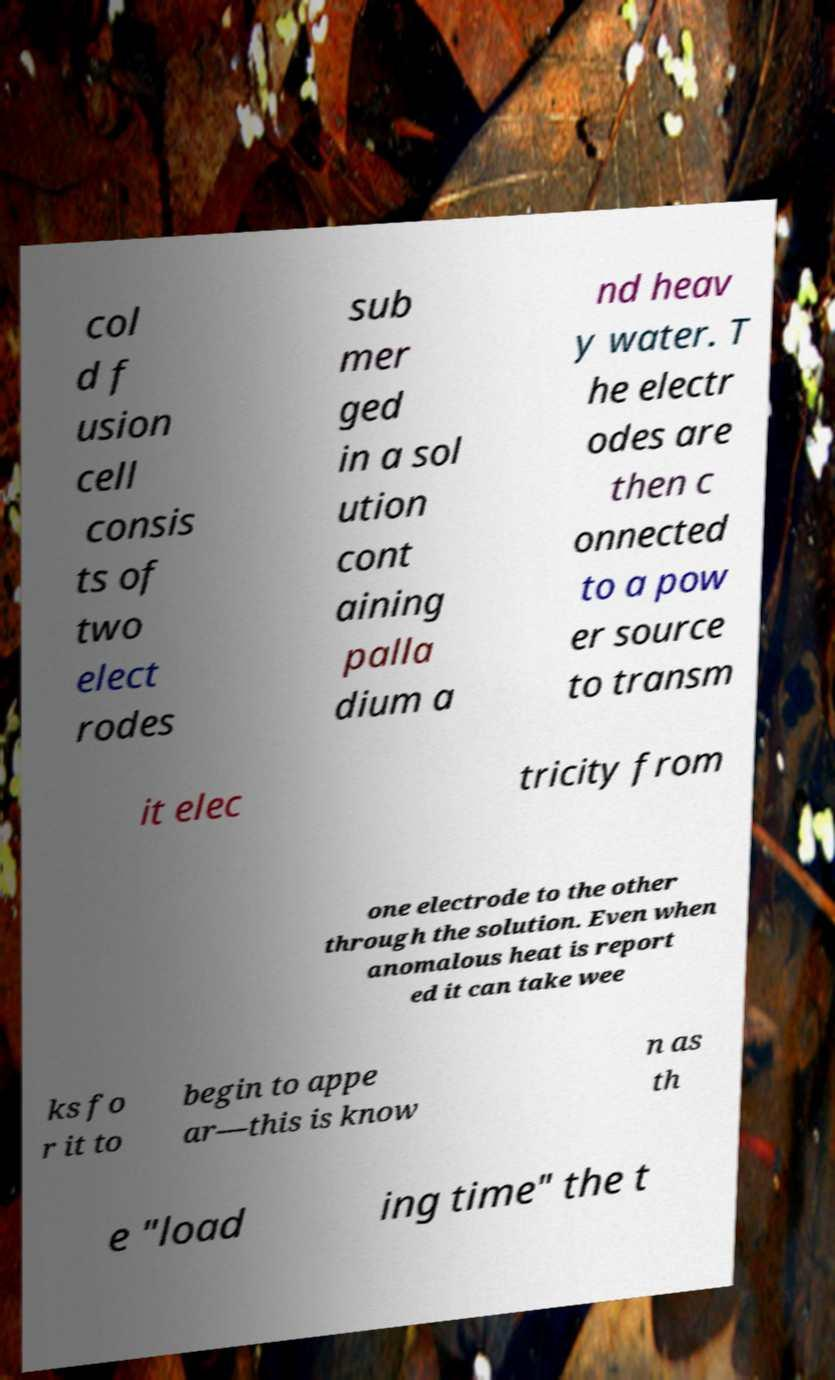For documentation purposes, I need the text within this image transcribed. Could you provide that? col d f usion cell consis ts of two elect rodes sub mer ged in a sol ution cont aining palla dium a nd heav y water. T he electr odes are then c onnected to a pow er source to transm it elec tricity from one electrode to the other through the solution. Even when anomalous heat is report ed it can take wee ks fo r it to begin to appe ar—this is know n as th e "load ing time" the t 